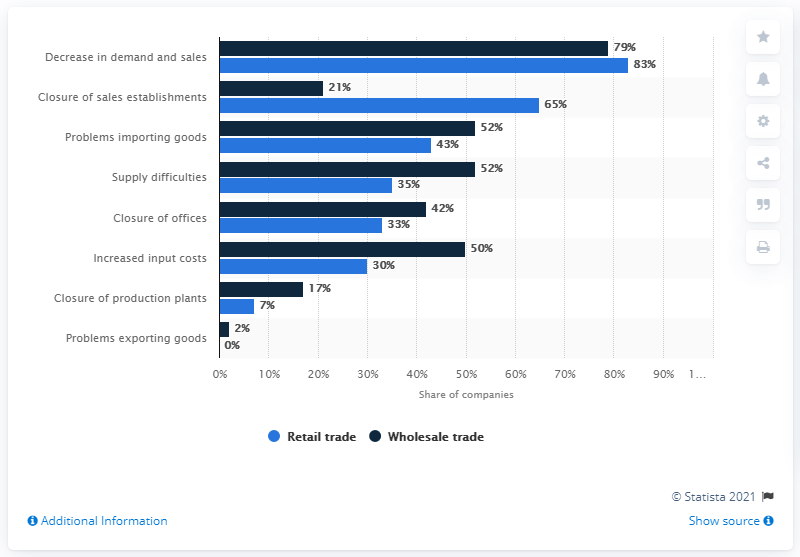Draw attention to some important aspects in this diagram. Eighty-three percent of retailers reported a decrease in demand and sales during the COVID-19 pandemic. 